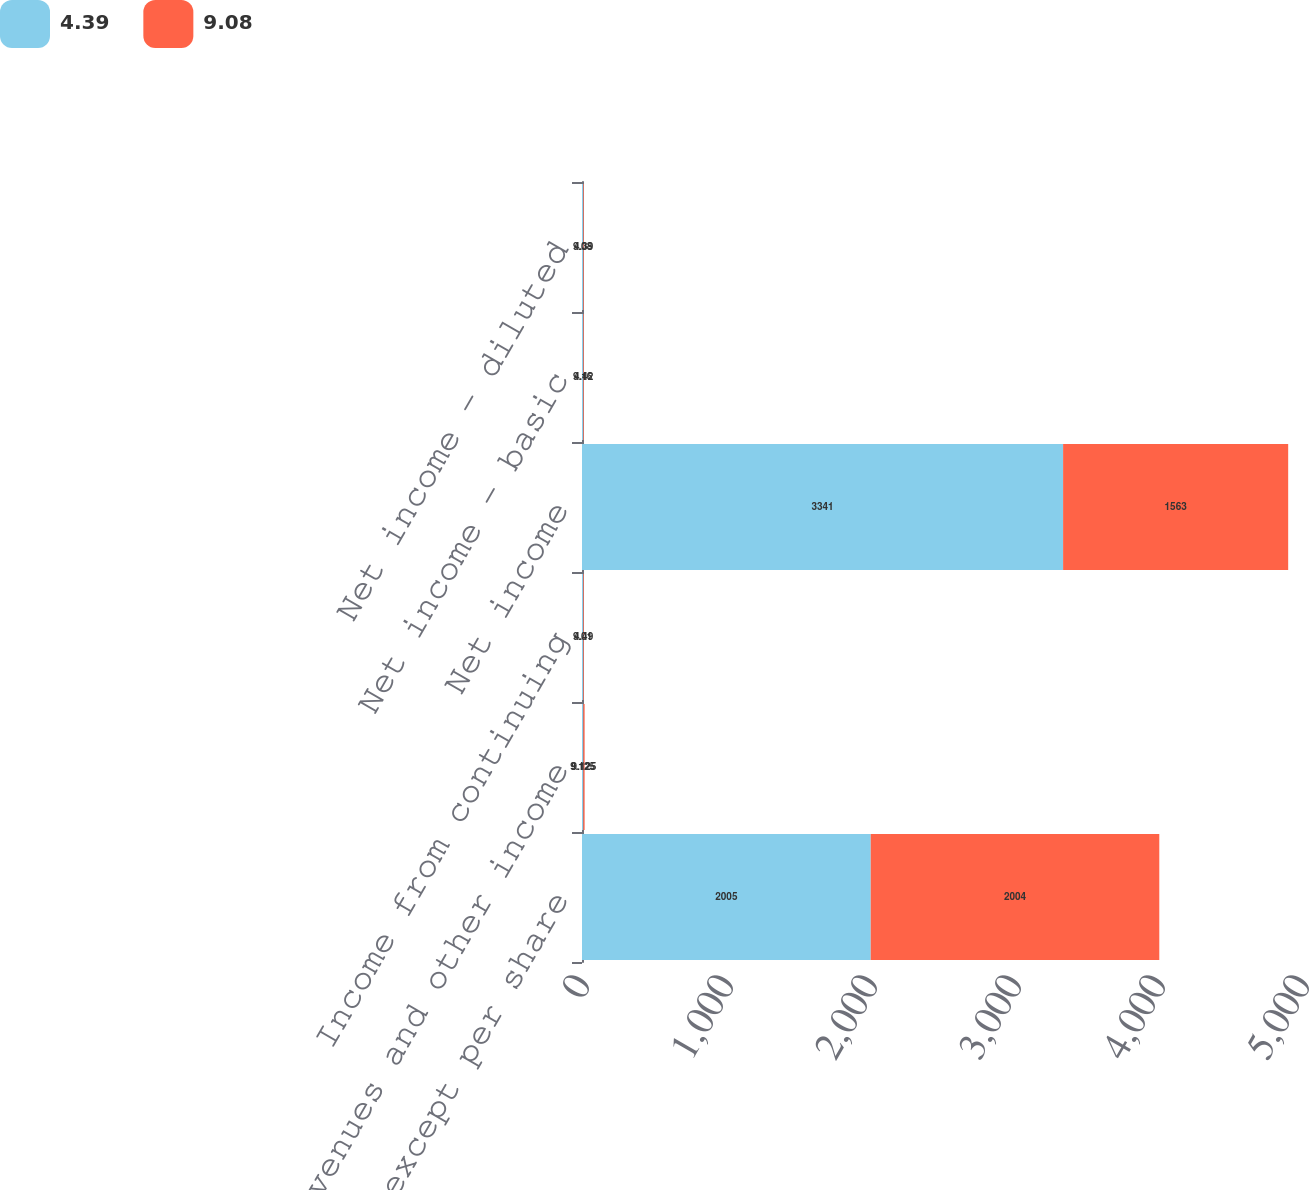<chart> <loc_0><loc_0><loc_500><loc_500><stacked_bar_chart><ecel><fcel>(In millions except per share<fcel>Revenues and other income<fcel>Income from continuing<fcel>Net income<fcel>Net income - basic<fcel>Net income - diluted<nl><fcel>4.39<fcel>2005<fcel>9.125<fcel>9.01<fcel>3341<fcel>9.16<fcel>9.08<nl><fcel>9.08<fcel>2004<fcel>9.125<fcel>4.49<fcel>1563<fcel>4.42<fcel>4.39<nl></chart> 